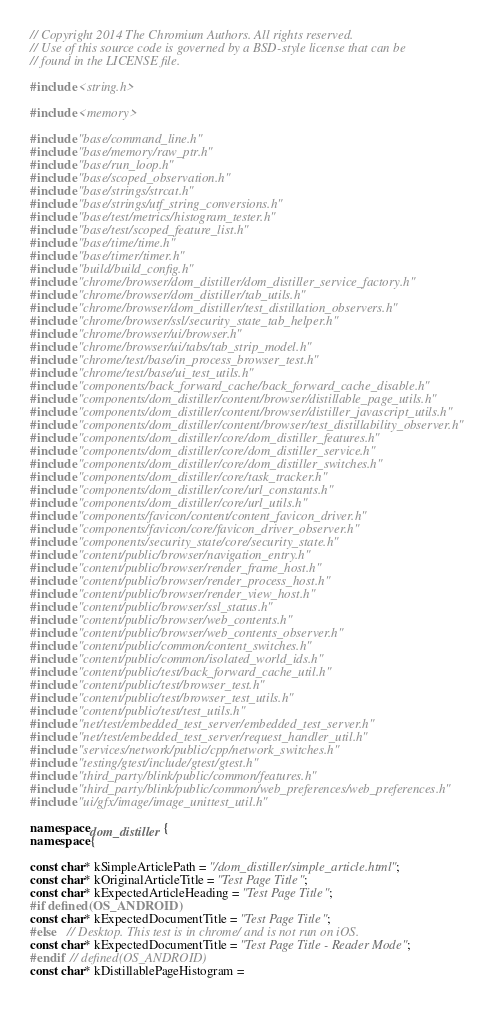Convert code to text. <code><loc_0><loc_0><loc_500><loc_500><_C++_>// Copyright 2014 The Chromium Authors. All rights reserved.
// Use of this source code is governed by a BSD-style license that can be
// found in the LICENSE file.

#include <string.h>

#include <memory>

#include "base/command_line.h"
#include "base/memory/raw_ptr.h"
#include "base/run_loop.h"
#include "base/scoped_observation.h"
#include "base/strings/strcat.h"
#include "base/strings/utf_string_conversions.h"
#include "base/test/metrics/histogram_tester.h"
#include "base/test/scoped_feature_list.h"
#include "base/time/time.h"
#include "base/timer/timer.h"
#include "build/build_config.h"
#include "chrome/browser/dom_distiller/dom_distiller_service_factory.h"
#include "chrome/browser/dom_distiller/tab_utils.h"
#include "chrome/browser/dom_distiller/test_distillation_observers.h"
#include "chrome/browser/ssl/security_state_tab_helper.h"
#include "chrome/browser/ui/browser.h"
#include "chrome/browser/ui/tabs/tab_strip_model.h"
#include "chrome/test/base/in_process_browser_test.h"
#include "chrome/test/base/ui_test_utils.h"
#include "components/back_forward_cache/back_forward_cache_disable.h"
#include "components/dom_distiller/content/browser/distillable_page_utils.h"
#include "components/dom_distiller/content/browser/distiller_javascript_utils.h"
#include "components/dom_distiller/content/browser/test_distillability_observer.h"
#include "components/dom_distiller/core/dom_distiller_features.h"
#include "components/dom_distiller/core/dom_distiller_service.h"
#include "components/dom_distiller/core/dom_distiller_switches.h"
#include "components/dom_distiller/core/task_tracker.h"
#include "components/dom_distiller/core/url_constants.h"
#include "components/dom_distiller/core/url_utils.h"
#include "components/favicon/content/content_favicon_driver.h"
#include "components/favicon/core/favicon_driver_observer.h"
#include "components/security_state/core/security_state.h"
#include "content/public/browser/navigation_entry.h"
#include "content/public/browser/render_frame_host.h"
#include "content/public/browser/render_process_host.h"
#include "content/public/browser/render_view_host.h"
#include "content/public/browser/ssl_status.h"
#include "content/public/browser/web_contents.h"
#include "content/public/browser/web_contents_observer.h"
#include "content/public/common/content_switches.h"
#include "content/public/common/isolated_world_ids.h"
#include "content/public/test/back_forward_cache_util.h"
#include "content/public/test/browser_test.h"
#include "content/public/test/browser_test_utils.h"
#include "content/public/test/test_utils.h"
#include "net/test/embedded_test_server/embedded_test_server.h"
#include "net/test/embedded_test_server/request_handler_util.h"
#include "services/network/public/cpp/network_switches.h"
#include "testing/gtest/include/gtest/gtest.h"
#include "third_party/blink/public/common/features.h"
#include "third_party/blink/public/common/web_preferences/web_preferences.h"
#include "ui/gfx/image/image_unittest_util.h"

namespace dom_distiller {
namespace {

const char* kSimpleArticlePath = "/dom_distiller/simple_article.html";
const char* kOriginalArticleTitle = "Test Page Title";
const char* kExpectedArticleHeading = "Test Page Title";
#if defined(OS_ANDROID)
const char* kExpectedDocumentTitle = "Test Page Title";
#else   // Desktop. This test is in chrome/ and is not run on iOS.
const char* kExpectedDocumentTitle = "Test Page Title - Reader Mode";
#endif  // defined(OS_ANDROID)
const char* kDistillablePageHistogram =</code> 